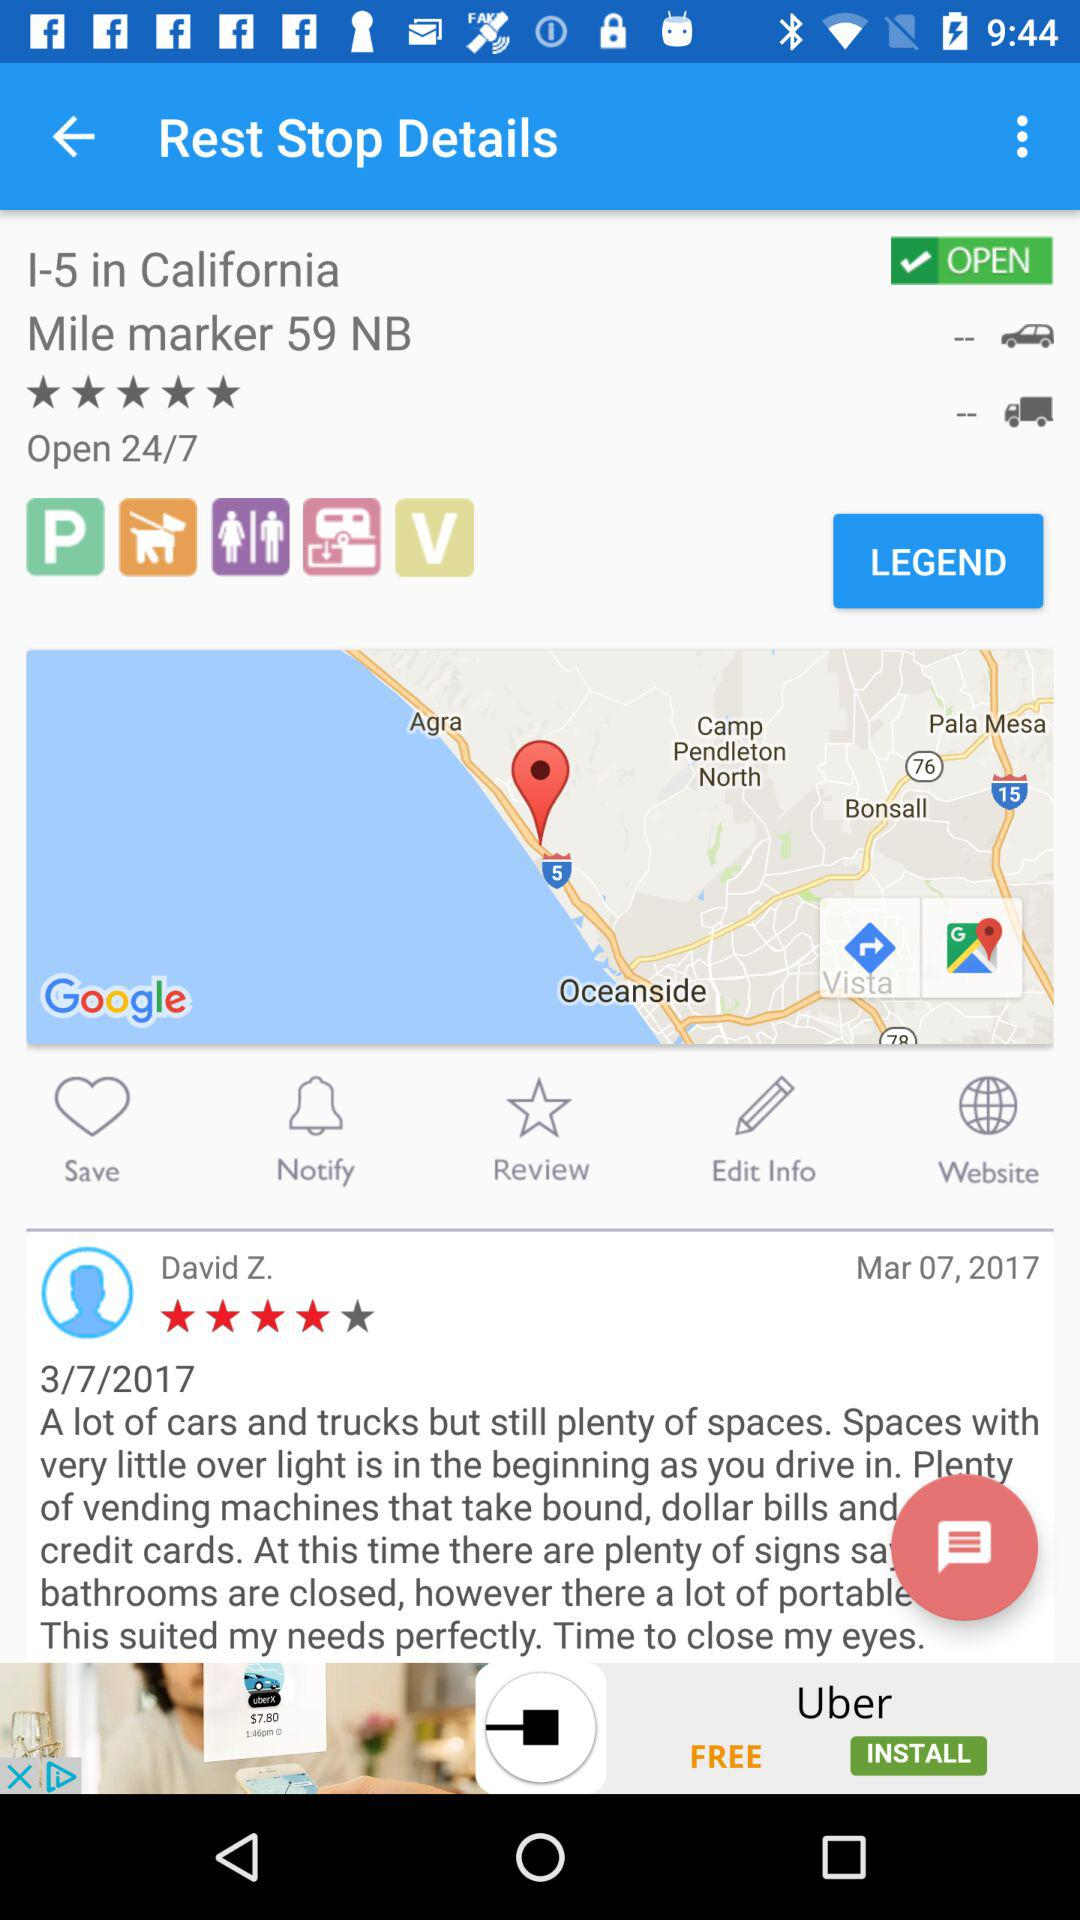What is the address shown? The address is I-5 in California, Mile Marker 59 NB. 